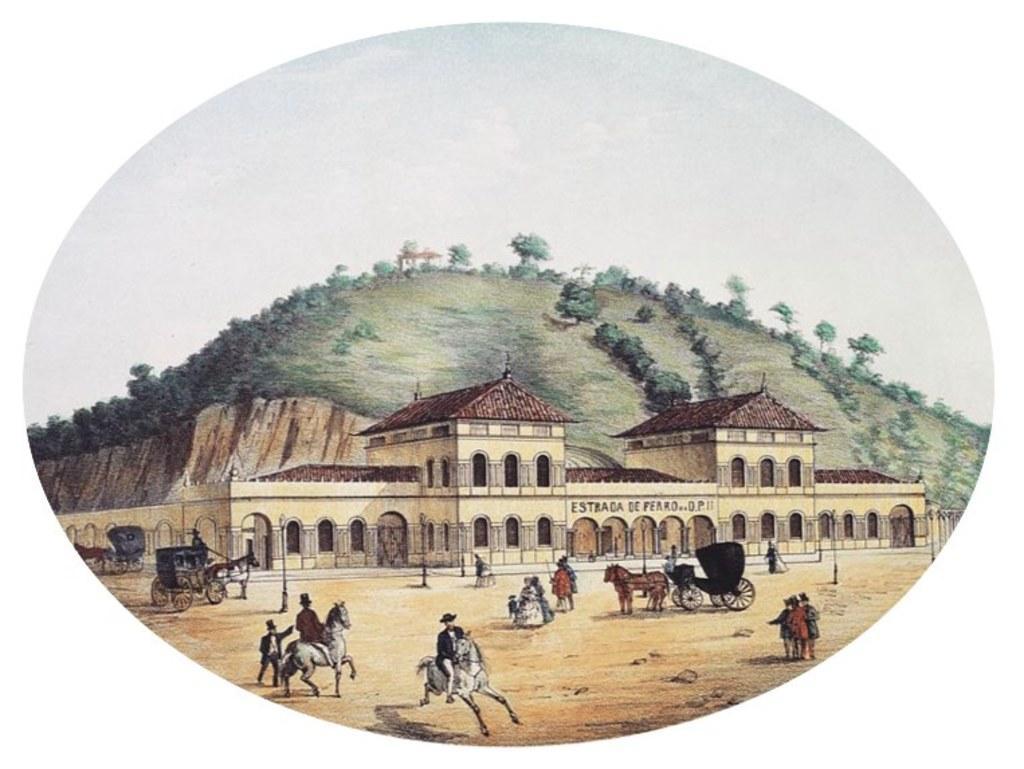Can you describe this image briefly? This is the picture of a drawing where we can see a building and in front of the building there are some people and horses. We can see some horse carts in the ground and in the background, we can see the mountain and some trees. 